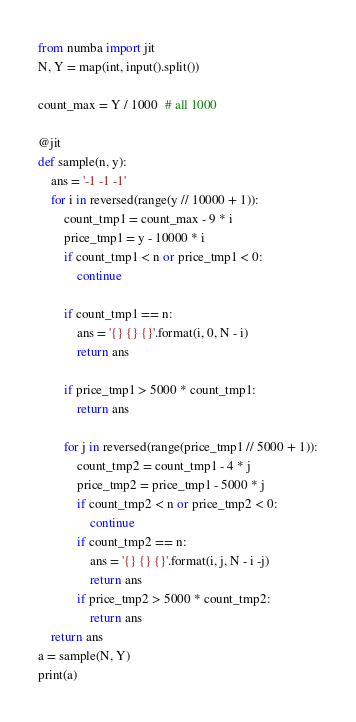<code> <loc_0><loc_0><loc_500><loc_500><_Python_>from numba import jit
N, Y = map(int, input().split())

count_max = Y / 1000  # all 1000

@jit
def sample(n, y):
    ans = '-1 -1 -1'
    for i in reversed(range(y // 10000 + 1)):
        count_tmp1 = count_max - 9 * i
        price_tmp1 = y - 10000 * i
        if count_tmp1 < n or price_tmp1 < 0:
            continue

        if count_tmp1 == n:
            ans = '{} {} {}'.format(i, 0, N - i)
            return ans

        if price_tmp1 > 5000 * count_tmp1:
            return ans

        for j in reversed(range(price_tmp1 // 5000 + 1)):
            count_tmp2 = count_tmp1 - 4 * j
            price_tmp2 = price_tmp1 - 5000 * j
            if count_tmp2 < n or price_tmp2 < 0:
                continue
            if count_tmp2 == n:
                ans = '{} {} {}'.format(i, j, N - i -j)
                return ans
            if price_tmp2 > 5000 * count_tmp2:
                return ans
    return ans
a = sample(N, Y)
print(a)</code> 